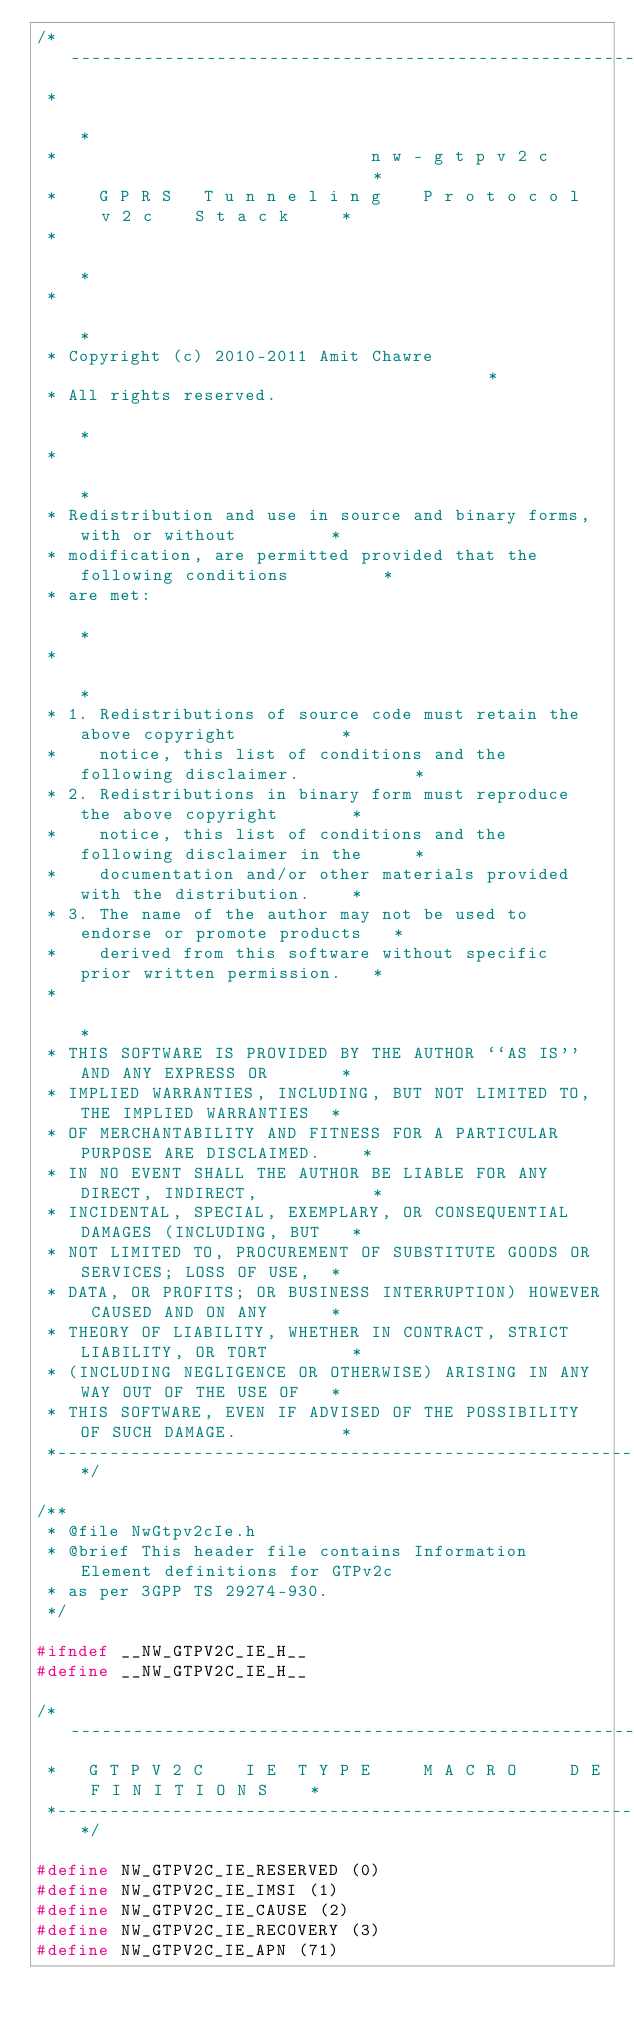<code> <loc_0><loc_0><loc_500><loc_500><_C_>/*----------------------------------------------------------------------------*
 *                                                                            *
 *                              n w - g t p v 2 c                             *
 *    G P R S   T u n n e l i n g    P r o t o c o l   v 2 c    S t a c k     *
 *                                                                            *
 *                                                                            *
 * Copyright (c) 2010-2011 Amit Chawre                                        *
 * All rights reserved.                                                       *
 *                                                                            *
 * Redistribution and use in source and binary forms, with or without         *
 * modification, are permitted provided that the following conditions         *
 * are met:                                                                   *
 *                                                                            *
 * 1. Redistributions of source code must retain the above copyright          *
 *    notice, this list of conditions and the following disclaimer.           *
 * 2. Redistributions in binary form must reproduce the above copyright       *
 *    notice, this list of conditions and the following disclaimer in the     *
 *    documentation and/or other materials provided with the distribution.    *
 * 3. The name of the author may not be used to endorse or promote products   *
 *    derived from this software without specific prior written permission.   *
 *                                                                            *
 * THIS SOFTWARE IS PROVIDED BY THE AUTHOR ``AS IS'' AND ANY EXPRESS OR       *
 * IMPLIED WARRANTIES, INCLUDING, BUT NOT LIMITED TO, THE IMPLIED WARRANTIES  *
 * OF MERCHANTABILITY AND FITNESS FOR A PARTICULAR PURPOSE ARE DISCLAIMED.    *
 * IN NO EVENT SHALL THE AUTHOR BE LIABLE FOR ANY DIRECT, INDIRECT,           *
 * INCIDENTAL, SPECIAL, EXEMPLARY, OR CONSEQUENTIAL DAMAGES (INCLUDING, BUT   *
 * NOT LIMITED TO, PROCUREMENT OF SUBSTITUTE GOODS OR SERVICES; LOSS OF USE,  *
 * DATA, OR PROFITS; OR BUSINESS INTERRUPTION) HOWEVER CAUSED AND ON ANY      *
 * THEORY OF LIABILITY, WHETHER IN CONTRACT, STRICT LIABILITY, OR TORT        *
 * (INCLUDING NEGLIGENCE OR OTHERWISE) ARISING IN ANY WAY OUT OF THE USE OF   *
 * THIS SOFTWARE, EVEN IF ADVISED OF THE POSSIBILITY OF SUCH DAMAGE.          *
 *----------------------------------------------------------------------------*/

/**
 * @file NwGtpv2cIe.h
 * @brief This header file contains Information Element definitions for GTPv2c
 * as per 3GPP TS 29274-930.
 */

#ifndef __NW_GTPV2C_IE_H__
#define __NW_GTPV2C_IE_H__

/*--------------------------------------------------------------------------*
 *   G T P V 2 C    I E  T Y P E     M A C R O     D E F I N I T I O N S    *
 *--------------------------------------------------------------------------*/

#define NW_GTPV2C_IE_RESERVED (0)
#define NW_GTPV2C_IE_IMSI (1)
#define NW_GTPV2C_IE_CAUSE (2)
#define NW_GTPV2C_IE_RECOVERY (3)
#define NW_GTPV2C_IE_APN (71)</code> 